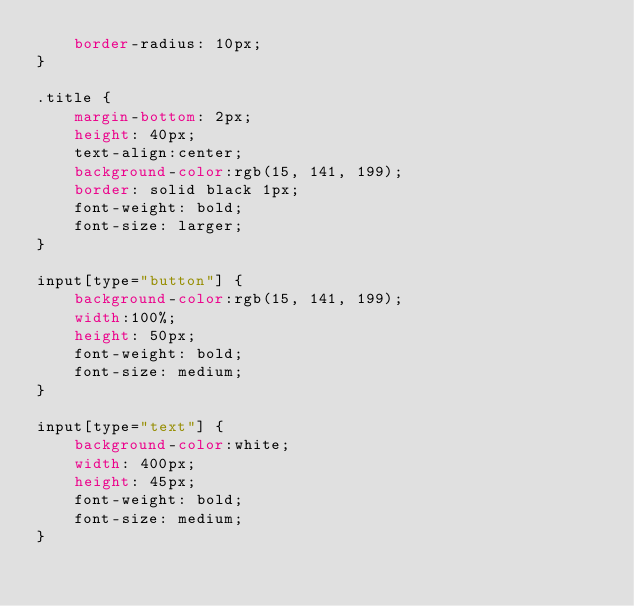<code> <loc_0><loc_0><loc_500><loc_500><_CSS_>    border-radius: 10px;
}

.title {
    margin-bottom: 2px;
    height: 40px;
    text-align:center;
    background-color:rgb(15, 141, 199);
    border: solid black 1px;
    font-weight: bold;
    font-size: larger;
}

input[type="button"] {
    background-color:rgb(15, 141, 199);
    width:100%;
    height: 50px;
    font-weight: bold;
    font-size: medium;
}

input[type="text"] {
    background-color:white;
    width: 400px;
    height: 45px;
    font-weight: bold;
    font-size: medium;
}</code> 